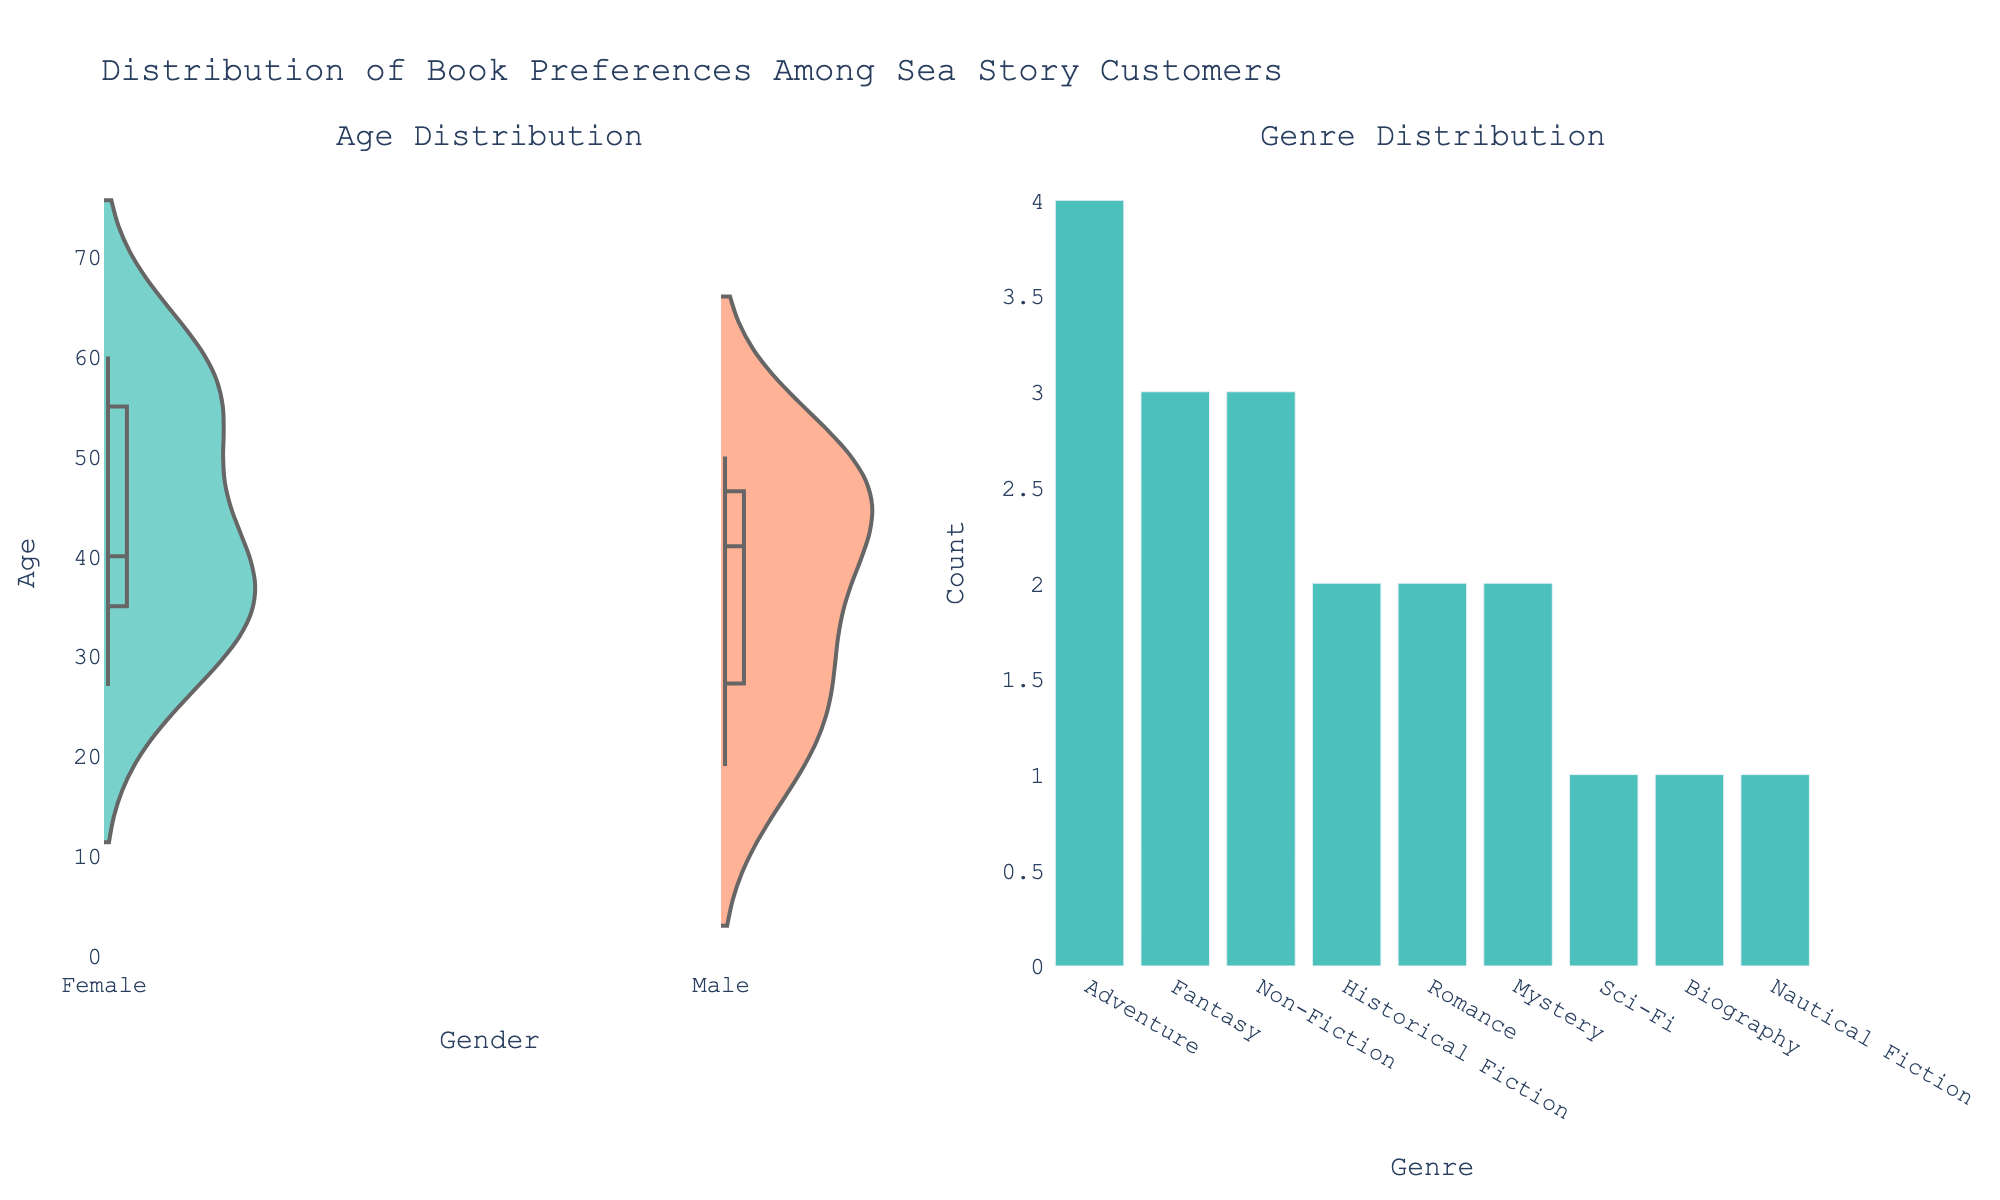What's the overall title of the figure? The title is often located at the top of the figure. Here, it provides a summary of the visual data representation.
Answer: Distribution of Book Preferences Among Sea Story Customers How many genres are represented in the genre distribution subplot? Look at the bar chart in the right subplot; each bar corresponds to a distinct genre. Count the number of bars.
Answer: 8 Which gender has a higher median age among the customers? Look at the central line inside each violin plot. This line represents the median. Compare the central lines for Male and Female.
Answer: Female What is the most preferred genre among the customers? Identify the tallest bar in the genre distribution subplot on the right. The genre associated with this bar is the most preferred.
Answer: Adventure Are there more male or female customers? Count the total occurrences of 'Male' and 'Female' in the violin plot on the left-hand side.
Answer: Female What is the age range of female customers based on the violin plot? Look at the female violin plot's vertical extent to identify the minimum and maximum ages.
Answer: 33 to 60 How many customers prefer Non-Fiction? Find the bar labeled "Non-Fiction" in the Genre Distribution subplot and check its height to find the count.
Answer: 3 Which genre has the least preference among the customers? Find the shortest bar in the genre distribution on the right side. The genre associated with this bar is the least preferred.
Answer: Nautical Fiction What is the average age of male customers who prefer Adventure genre? Isolate the data points for male customers preferring Adventure from the age distribution. The ages are 22, 29, and 19. Average these values by summing and dividing by the count.
Answer: 23.33 Is there any difference in the spread of ages between genders? Visually inspect the width of the violin plots on the left subplot. Assess which gender's plot shows a more significant spread (wider) versus less spread (narrower).
Answer: Yes, females have a wider spread in age 